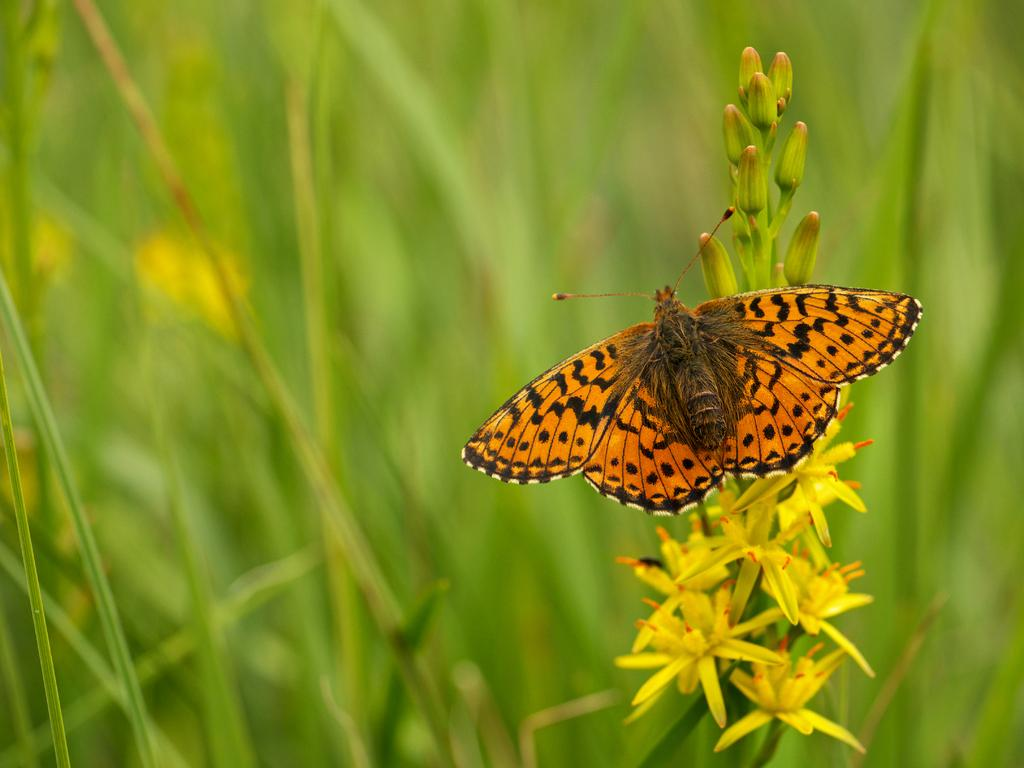What is the main subject of the image? The main subject of the image is a butterfly. What is the butterfly resting on? The butterfly is on yellow and orange color flowers. What colors can be seen on the butterfly? The butterfly has orange and black colors. What color is the background of the image? The background of the image is green. Can you see any bags hanging from the trees in the image? There are no bags or trees present in the image; it features a butterfly on flowers with a green background. Is there a crack visible on the butterfly's wing in the image? There is no crack visible on the butterfly's wing in the image; it appears to be intact with orange and black colors. 